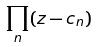Convert formula to latex. <formula><loc_0><loc_0><loc_500><loc_500>\prod _ { n } ( z - c _ { n } )</formula> 